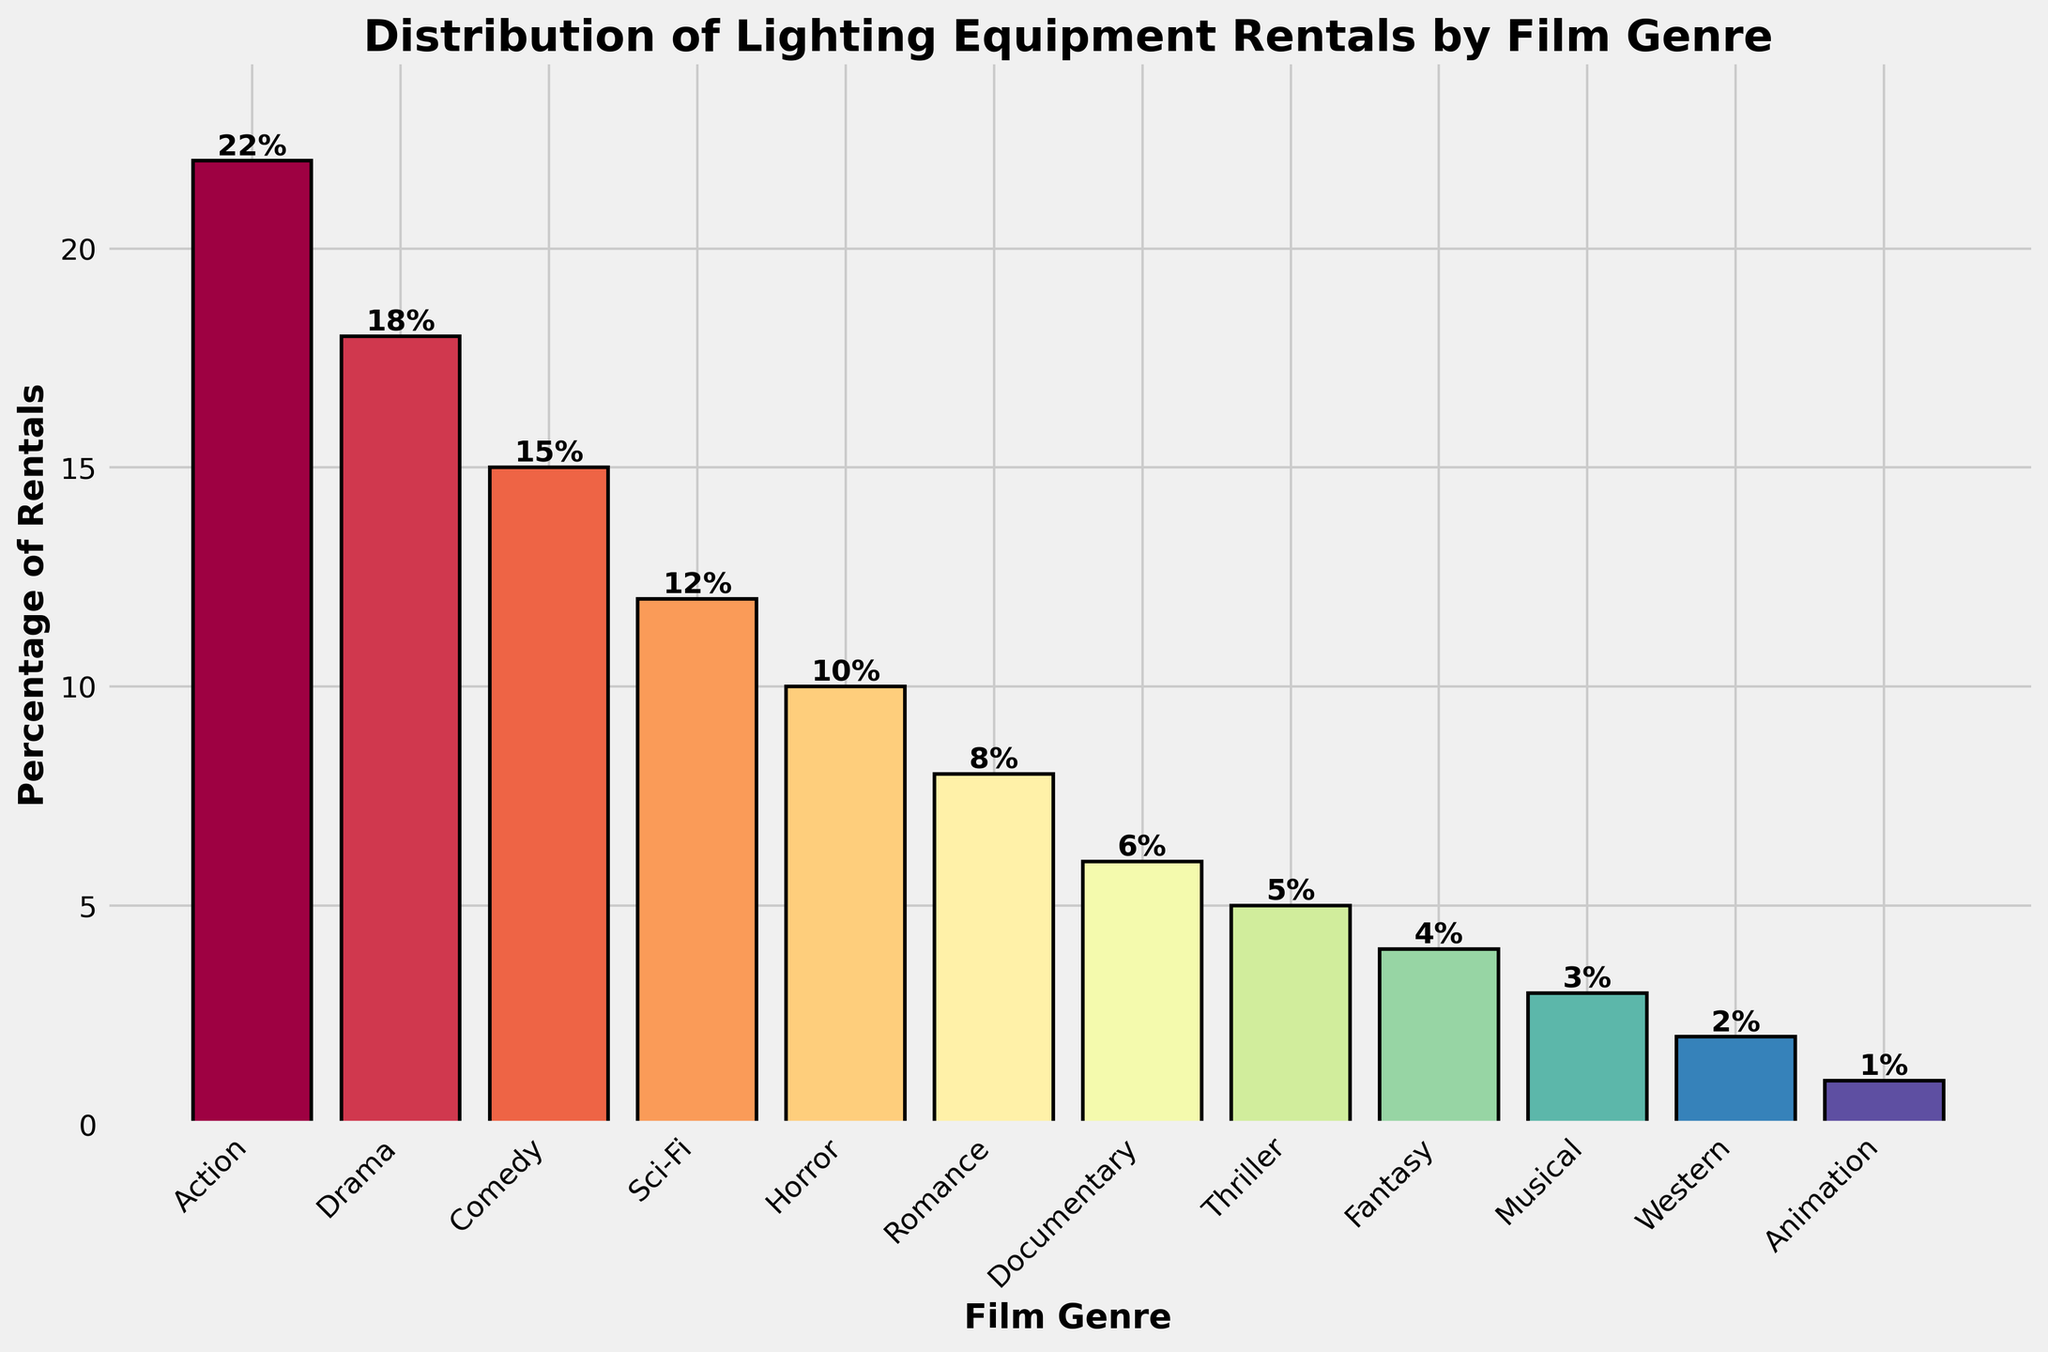Which genre has the highest percentage of lighting equipment rentals? By examining the height of the bars, we can see that the 'Action' genre has the highest percentage of lighting equipment rentals at 22%.
Answer: Action Comparing Sci-Fi and Horror genres, which has a higher percentage of lighting equipment rentals and by how much? The height of the bars indicates that Sci-Fi has 12% and Horror has 10%. The difference is calculated as 12% - 10% = 2%.
Answer: Sci-Fi by 2% What is the combined percentage of lighting equipment rentals for the Drama and Comedy genres? According to the figure, Drama has 18% and Comedy has 15%. Therefore, the combined percentage is 18% + 15% = 33%.
Answer: 33% Which genre has the smallest percentage of lighting equipment rentals and what is that percentage? The bar representing the 'Animation' genre is the shortest with a height indicating 1%.
Answer: Animation, 1% How many genres have a percentage of lighting equipment rentals that is less than or equal to 5%? By carefully examining the heights of the bars, we see that there are three genres: Thriller (5%), Fantasy (4%), and Animation (1%).
Answer: 3 What is the average percentage of lighting equipment rentals for the Romance, Western, and Musical genres? Romance has 8%, Western has 2%, and Musical has 3%. The average is calculated as (8% + 2% + 3%) / 3 = 4.33%.
Answer: 4.33% Which genre has a higher percentage of lighting equipment rentals, Documentary or Romance? From the heights of the bars, Romance has 8% and Documentary has 6%. Therefore, Romance has the higher percentage.
Answer: Romance What is the total percentage of lighting equipment rentals for genres that are utilized by at least 10% of the productions? By summing the percentages of genres used by 10% or more: Action (22%), Drama (18%), Comedy (15%), Sci-Fi (12%), and Horror (10%), the total is 77%.
Answer: 77% Among the genres with the lowest three percentages of lighting equipment rentals, which one uses the least? According to the bars, the lowest three percentages are Fantasy (4%), Musical (3%), and Animation (1%). Animation uses the least.
Answer: Animation What is the difference in the percentage of lighting equipment rentals between the highest and lowest represented genres? The highest percentage is for Action (22%) and the lowest is for Animation (1%). The difference is 22% - 1% = 21%.
Answer: 21% 